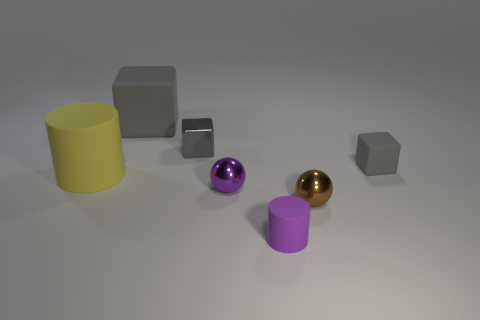Can you tell me the different textures of the objects in the image? Certainly. The yellow cylinder and the silver cube appear to have a matte surface, diffusing the light softly. The purple sphere and the golden ball, on the other hand, have a shiny, reflective surface which creates highlights and clear reflections of the environment. 